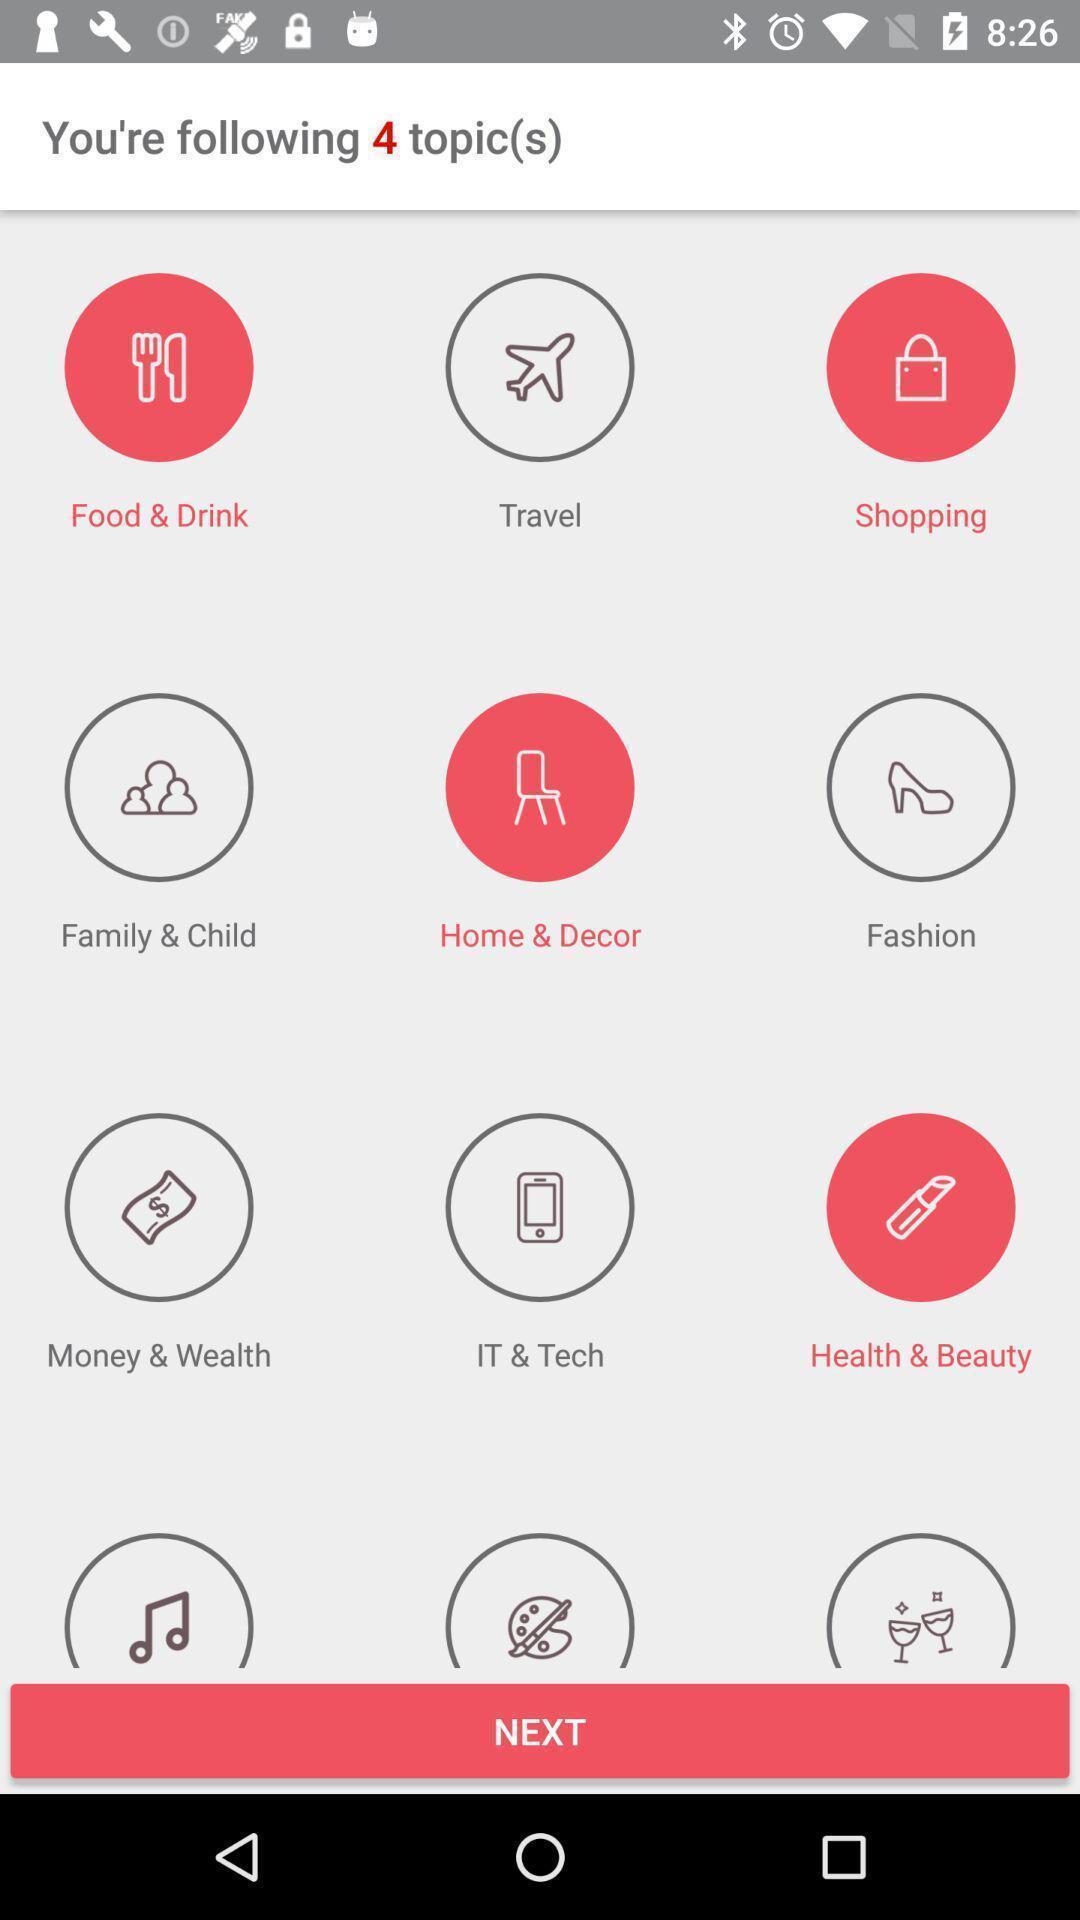What is the overall content of this screenshot? Screen displaying selected topics with next options. 